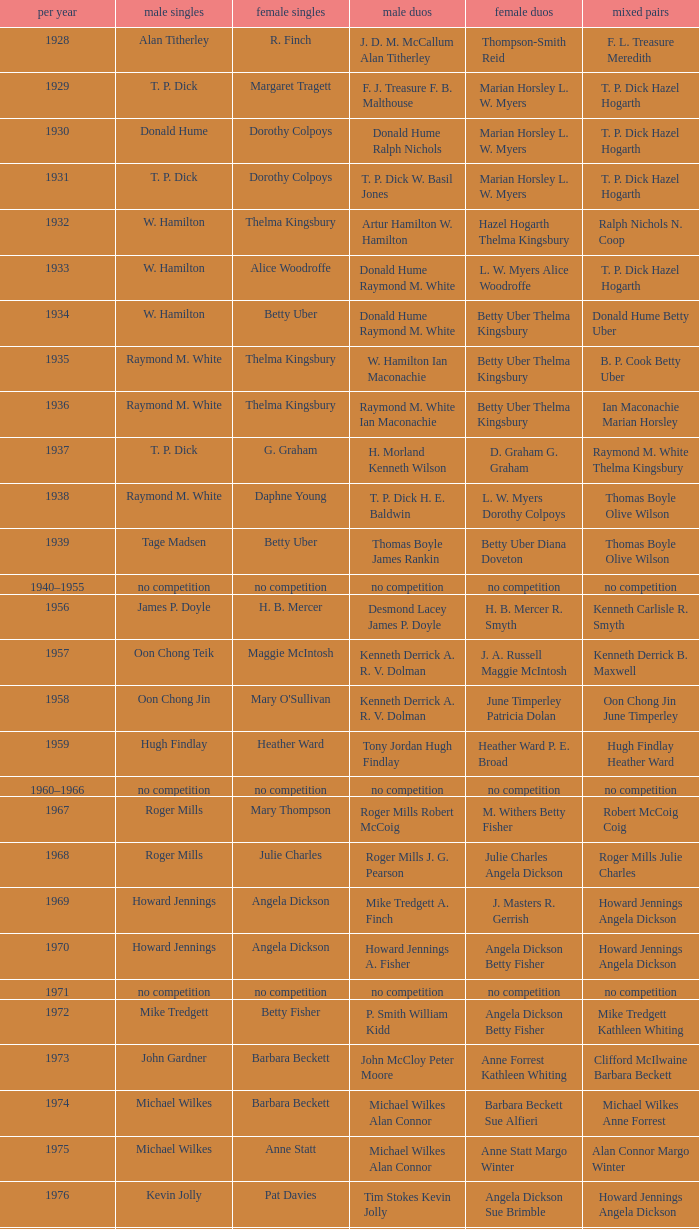Can you give me this table as a dict? {'header': ['per year', 'male singles', 'female singles', 'male duos', 'female duos', 'mixed pairs'], 'rows': [['1928', 'Alan Titherley', 'R. Finch', 'J. D. M. McCallum Alan Titherley', 'Thompson-Smith Reid', 'F. L. Treasure Meredith'], ['1929', 'T. P. Dick', 'Margaret Tragett', 'F. J. Treasure F. B. Malthouse', 'Marian Horsley L. W. Myers', 'T. P. Dick Hazel Hogarth'], ['1930', 'Donald Hume', 'Dorothy Colpoys', 'Donald Hume Ralph Nichols', 'Marian Horsley L. W. Myers', 'T. P. Dick Hazel Hogarth'], ['1931', 'T. P. Dick', 'Dorothy Colpoys', 'T. P. Dick W. Basil Jones', 'Marian Horsley L. W. Myers', 'T. P. Dick Hazel Hogarth'], ['1932', 'W. Hamilton', 'Thelma Kingsbury', 'Artur Hamilton W. Hamilton', 'Hazel Hogarth Thelma Kingsbury', 'Ralph Nichols N. Coop'], ['1933', 'W. Hamilton', 'Alice Woodroffe', 'Donald Hume Raymond M. White', 'L. W. Myers Alice Woodroffe', 'T. P. Dick Hazel Hogarth'], ['1934', 'W. Hamilton', 'Betty Uber', 'Donald Hume Raymond M. White', 'Betty Uber Thelma Kingsbury', 'Donald Hume Betty Uber'], ['1935', 'Raymond M. White', 'Thelma Kingsbury', 'W. Hamilton Ian Maconachie', 'Betty Uber Thelma Kingsbury', 'B. P. Cook Betty Uber'], ['1936', 'Raymond M. White', 'Thelma Kingsbury', 'Raymond M. White Ian Maconachie', 'Betty Uber Thelma Kingsbury', 'Ian Maconachie Marian Horsley'], ['1937', 'T. P. Dick', 'G. Graham', 'H. Morland Kenneth Wilson', 'D. Graham G. Graham', 'Raymond M. White Thelma Kingsbury'], ['1938', 'Raymond M. White', 'Daphne Young', 'T. P. Dick H. E. Baldwin', 'L. W. Myers Dorothy Colpoys', 'Thomas Boyle Olive Wilson'], ['1939', 'Tage Madsen', 'Betty Uber', 'Thomas Boyle James Rankin', 'Betty Uber Diana Doveton', 'Thomas Boyle Olive Wilson'], ['1940–1955', 'no competition', 'no competition', 'no competition', 'no competition', 'no competition'], ['1956', 'James P. Doyle', 'H. B. Mercer', 'Desmond Lacey James P. Doyle', 'H. B. Mercer R. Smyth', 'Kenneth Carlisle R. Smyth'], ['1957', 'Oon Chong Teik', 'Maggie McIntosh', 'Kenneth Derrick A. R. V. Dolman', 'J. A. Russell Maggie McIntosh', 'Kenneth Derrick B. Maxwell'], ['1958', 'Oon Chong Jin', "Mary O'Sullivan", 'Kenneth Derrick A. R. V. Dolman', 'June Timperley Patricia Dolan', 'Oon Chong Jin June Timperley'], ['1959', 'Hugh Findlay', 'Heather Ward', 'Tony Jordan Hugh Findlay', 'Heather Ward P. E. Broad', 'Hugh Findlay Heather Ward'], ['1960–1966', 'no competition', 'no competition', 'no competition', 'no competition', 'no competition'], ['1967', 'Roger Mills', 'Mary Thompson', 'Roger Mills Robert McCoig', 'M. Withers Betty Fisher', 'Robert McCoig Coig'], ['1968', 'Roger Mills', 'Julie Charles', 'Roger Mills J. G. Pearson', 'Julie Charles Angela Dickson', 'Roger Mills Julie Charles'], ['1969', 'Howard Jennings', 'Angela Dickson', 'Mike Tredgett A. Finch', 'J. Masters R. Gerrish', 'Howard Jennings Angela Dickson'], ['1970', 'Howard Jennings', 'Angela Dickson', 'Howard Jennings A. Fisher', 'Angela Dickson Betty Fisher', 'Howard Jennings Angela Dickson'], ['1971', 'no competition', 'no competition', 'no competition', 'no competition', 'no competition'], ['1972', 'Mike Tredgett', 'Betty Fisher', 'P. Smith William Kidd', 'Angela Dickson Betty Fisher', 'Mike Tredgett Kathleen Whiting'], ['1973', 'John Gardner', 'Barbara Beckett', 'John McCloy Peter Moore', 'Anne Forrest Kathleen Whiting', 'Clifford McIlwaine Barbara Beckett'], ['1974', 'Michael Wilkes', 'Barbara Beckett', 'Michael Wilkes Alan Connor', 'Barbara Beckett Sue Alfieri', 'Michael Wilkes Anne Forrest'], ['1975', 'Michael Wilkes', 'Anne Statt', 'Michael Wilkes Alan Connor', 'Anne Statt Margo Winter', 'Alan Connor Margo Winter'], ['1976', 'Kevin Jolly', 'Pat Davies', 'Tim Stokes Kevin Jolly', 'Angela Dickson Sue Brimble', 'Howard Jennings Angela Dickson'], ['1977', 'David Eddy', 'Paula Kilvington', 'David Eddy Eddy Sutton', 'Anne Statt Jane Webster', 'David Eddy Barbara Giles'], ['1978', 'Mike Tredgett', 'Gillian Gilks', 'David Eddy Eddy Sutton', 'Barbara Sutton Marjan Ridder', 'Elliot Stuart Gillian Gilks'], ['1979', 'Kevin Jolly', 'Nora Perry', 'Ray Stevens Mike Tredgett', 'Barbara Sutton Nora Perry', 'Mike Tredgett Nora Perry'], ['1980', 'Thomas Kihlström', 'Jane Webster', 'Thomas Kihlström Bengt Fröman', 'Jane Webster Karen Puttick', 'Billy Gilliland Karen Puttick'], ['1981', 'Ray Stevens', 'Gillian Gilks', 'Ray Stevens Mike Tredgett', 'Gillian Gilks Paula Kilvington', 'Mike Tredgett Nora Perry'], ['1982', 'Steve Baddeley', 'Karen Bridge', 'David Eddy Eddy Sutton', 'Karen Chapman Sally Podger', 'Billy Gilliland Karen Chapman'], ['1983', 'Steve Butler', 'Sally Podger', 'Mike Tredgett Dipak Tailor', 'Nora Perry Jane Webster', 'Dipak Tailor Nora Perry'], ['1984', 'Steve Butler', 'Karen Beckman', 'Mike Tredgett Martin Dew', 'Helen Troke Karen Chapman', 'Mike Tredgett Karen Chapman'], ['1985', 'Morten Frost', 'Charlotte Hattens', 'Billy Gilliland Dan Travers', 'Gillian Gilks Helen Troke', 'Martin Dew Gillian Gilks'], ['1986', 'Darren Hall', 'Fiona Elliott', 'Martin Dew Dipak Tailor', 'Karen Beckman Sara Halsall', 'Jesper Knudsen Nettie Nielsen'], ['1987', 'Darren Hall', 'Fiona Elliott', 'Martin Dew Darren Hall', 'Karen Beckman Sara Halsall', 'Martin Dew Gillian Gilks'], ['1988', 'Vimal Kumar', 'Lee Jung-mi', 'Richard Outterside Mike Brown', 'Fiona Elliott Sara Halsall', 'Martin Dew Gillian Gilks'], ['1989', 'Darren Hall', 'Bang Soo-hyun', 'Nick Ponting Dave Wright', 'Karen Beckman Sara Sankey', 'Mike Brown Jillian Wallwork'], ['1990', 'Mathew Smith', 'Joanne Muggeridge', 'Nick Ponting Dave Wright', 'Karen Chapman Sara Sankey', 'Dave Wright Claire Palmer'], ['1991', 'Vimal Kumar', 'Denyse Julien', 'Nick Ponting Dave Wright', 'Cheryl Johnson Julie Bradbury', 'Nick Ponting Joanne Wright'], ['1992', 'Wei Yan', 'Fiona Smith', 'Michael Adams Chris Rees', 'Denyse Julien Doris Piché', 'Andy Goode Joanne Wright'], ['1993', 'Anders Nielsen', 'Sue Louis Lane', 'Nick Ponting Dave Wright', 'Julie Bradbury Sara Sankey', 'Nick Ponting Joanne Wright'], ['1994', 'Darren Hall', 'Marina Andrievskaya', 'Michael Adams Simon Archer', 'Julie Bradbury Joanne Wright', 'Chris Hunt Joanne Wright'], ['1995', 'Peter Rasmussen', 'Denyse Julien', 'Andrei Andropov Nikolai Zuyev', 'Julie Bradbury Joanne Wright', 'Nick Ponting Joanne Wright'], ['1996', 'Colin Haughton', 'Elena Rybkina', 'Andrei Andropov Nikolai Zuyev', 'Elena Rybkina Marina Yakusheva', 'Nikolai Zuyev Marina Yakusheva'], ['1997', 'Chris Bruil', 'Kelly Morgan', 'Ian Pearson James Anderson', 'Nicole van Hooren Brenda Conijn', 'Quinten van Dalm Nicole van Hooren'], ['1998', 'Dicky Palyama', 'Brenda Beenhakker', 'James Anderson Ian Sullivan', 'Sara Sankey Ella Tripp', 'James Anderson Sara Sankey'], ['1999', 'Daniel Eriksson', 'Marina Andrievskaya', 'Joachim Tesche Jean-Philippe Goyette', 'Marina Andrievskaya Catrine Bengtsson', 'Henrik Andersson Marina Andrievskaya'], ['2000', 'Richard Vaughan', 'Marina Yakusheva', 'Joachim Andersson Peter Axelsson', 'Irina Ruslyakova Marina Yakusheva', 'Peter Jeffrey Joanne Davies'], ['2001', 'Irwansyah', 'Brenda Beenhakker', 'Vincent Laigle Svetoslav Stoyanov', 'Sara Sankey Ella Tripp', 'Nikolai Zuyev Marina Yakusheva'], ['2002', 'Irwansyah', 'Karina de Wit', 'Nikolai Zuyev Stanislav Pukhov', 'Ella Tripp Joanne Wright', 'Nikolai Zuyev Marina Yakusheva'], ['2003', 'Irwansyah', 'Ella Karachkova', 'Ashley Thilthorpe Kristian Roebuck', 'Ella Karachkova Anastasia Russkikh', 'Alexandr Russkikh Anastasia Russkikh'], ['2004', 'Nathan Rice', 'Petya Nedelcheva', 'Reuben Gordown Aji Basuki Sindoro', 'Petya Nedelcheva Yuan Wemyss', 'Matthew Hughes Kelly Morgan'], ['2005', 'Chetan Anand', 'Eleanor Cox', 'Andrew Ellis Dean George', 'Hayley Connor Heather Olver', 'Valiyaveetil Diju Jwala Gutta'], ['2006', 'Irwansyah', 'Huang Chia-chi', 'Matthew Hughes Martyn Lewis', 'Natalie Munt Mariana Agathangelou', 'Kristian Roebuck Natalie Munt'], ['2007', 'Marc Zwiebler', 'Jill Pittard', 'Wojciech Szkudlarczyk Adam Cwalina', 'Chloe Magee Bing Huang', 'Wojciech Szkudlarczyk Malgorzata Kurdelska'], ['2008', 'Brice Leverdez', 'Kati Tolmoff', 'Andrew Bowman Martyn Lewis', 'Mariana Agathangelou Jillie Cooper', 'Watson Briggs Jillie Cooper'], ['2009', 'Kristian Nielsen', 'Tatjana Bibik', 'Vitaliy Durkin Alexandr Nikolaenko', 'Valeria Sorokina Nina Vislova', 'Vitaliy Durkin Nina Vislova'], ['2010', 'Pablo Abián', 'Anita Raj Kaur', 'Peter Käsbauer Josche Zurwonne', 'Joanne Quay Swee Ling Anita Raj Kaur', 'Peter Käsbauer Johanna Goliszewski'], ['2011', 'Niluka Karunaratne', 'Nicole Schaller', 'Chris Coles Matthew Nottingham', 'Ng Hui Ern Ng Hui Lin', 'Martin Campbell Ng Hui Lin'], ['2012', 'Chou Tien-chen', 'Chiang Mei-hui', 'Marcus Ellis Paul Van Rietvelde', 'Gabrielle White Lauren Smith', 'Marcus Ellis Gabrielle White']]} Who won the Men's singles in the year that Ian Maconachie Marian Horsley won the Mixed doubles? Raymond M. White. 